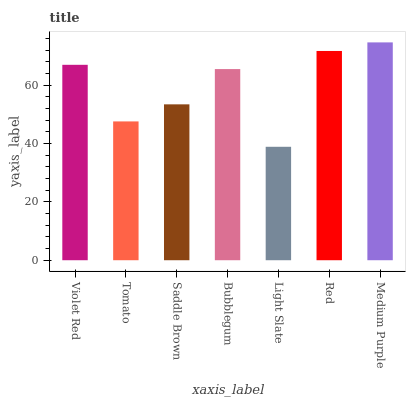Is Light Slate the minimum?
Answer yes or no. Yes. Is Medium Purple the maximum?
Answer yes or no. Yes. Is Tomato the minimum?
Answer yes or no. No. Is Tomato the maximum?
Answer yes or no. No. Is Violet Red greater than Tomato?
Answer yes or no. Yes. Is Tomato less than Violet Red?
Answer yes or no. Yes. Is Tomato greater than Violet Red?
Answer yes or no. No. Is Violet Red less than Tomato?
Answer yes or no. No. Is Bubblegum the high median?
Answer yes or no. Yes. Is Bubblegum the low median?
Answer yes or no. Yes. Is Saddle Brown the high median?
Answer yes or no. No. Is Red the low median?
Answer yes or no. No. 